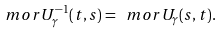<formula> <loc_0><loc_0><loc_500><loc_500>\ m o r { U } _ { \gamma } ^ { - 1 } ( t , s ) = \ m o r { U } _ { \gamma } ( s , t ) .</formula> 